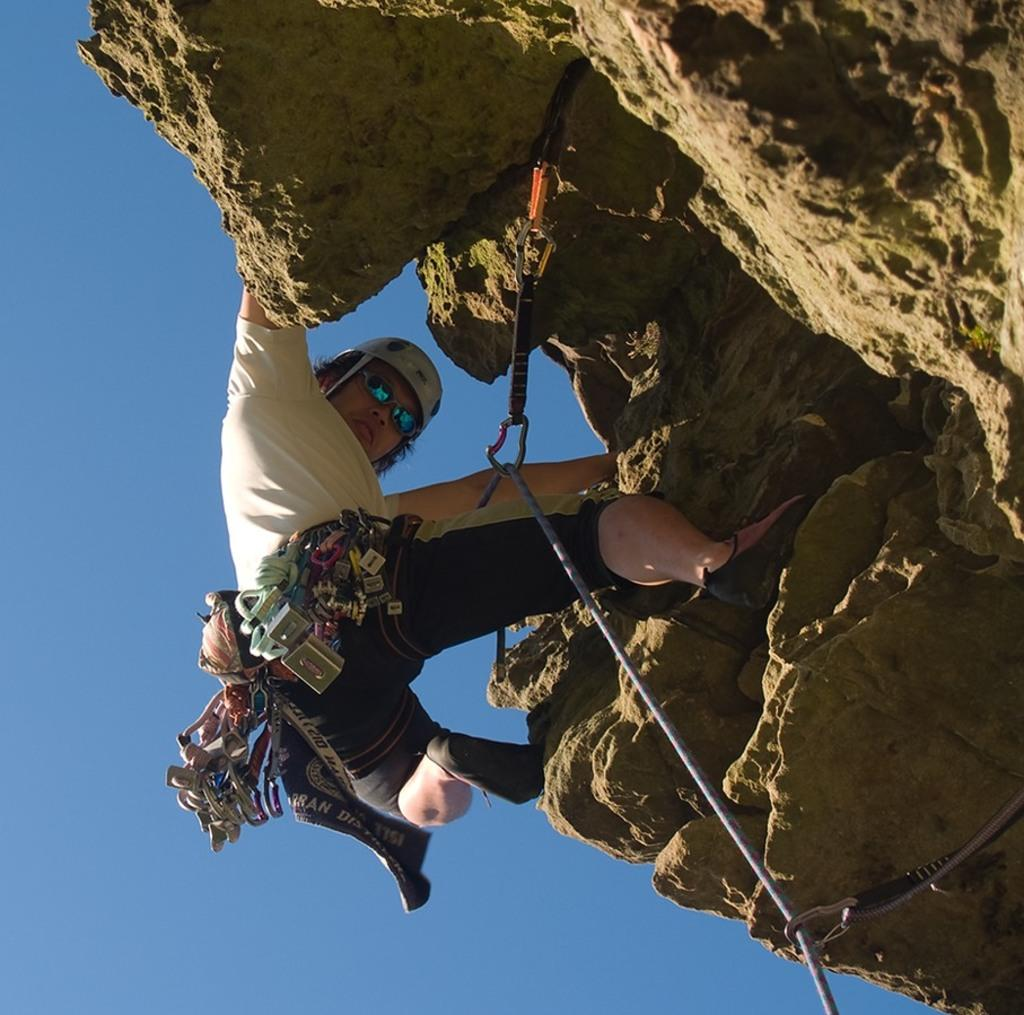What is the main activity being performed by the person in the image? The person is climbing a mountain in the image. How is the person secured while climbing the mountain? The person is tied with a rope. What can be seen on the right side of the image? There is a rock on the right side of the image. What is visible at the top of the image? The sky is visible at the top of the image. What type of beef is being served in the garden in the image? There is no beef or garden present in the image; it features a person climbing a mountain with a rock on the right side and the sky visible at the top. 